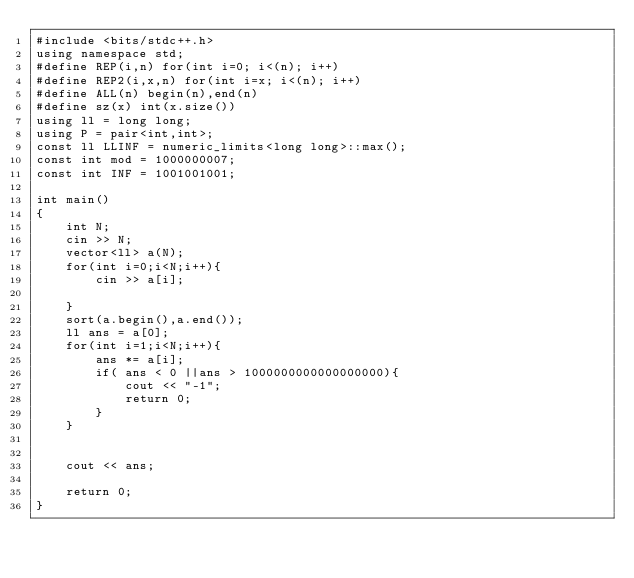Convert code to text. <code><loc_0><loc_0><loc_500><loc_500><_C++_>#include <bits/stdc++.h>
using namespace std;
#define REP(i,n) for(int i=0; i<(n); i++)
#define REP2(i,x,n) for(int i=x; i<(n); i++)
#define ALL(n) begin(n),end(n)
#define sz(x) int(x.size())
using ll = long long;
using P = pair<int,int>;
const ll LLINF = numeric_limits<long long>::max();
const int mod = 1000000007;
const int INF = 1001001001;

int main()
{
    int N;
    cin >> N;
    vector<ll> a(N);
    for(int i=0;i<N;i++){
        cin >> a[i];

    }
    sort(a.begin(),a.end());
    ll ans = a[0];
    for(int i=1;i<N;i++){
        ans *= a[i];
        if( ans < 0 ||ans > 1000000000000000000){
            cout << "-1";
            return 0;
        }
    }
    

    cout << ans;

    return 0;
}</code> 